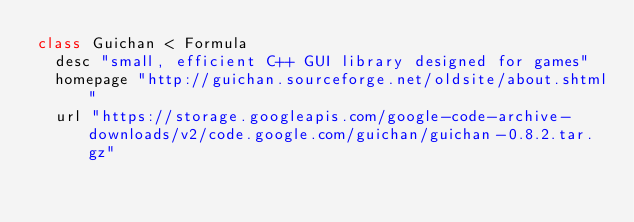Convert code to text. <code><loc_0><loc_0><loc_500><loc_500><_Ruby_>class Guichan < Formula
  desc "small, efficient C++ GUI library designed for games"
  homepage "http://guichan.sourceforge.net/oldsite/about.shtml"
  url "https://storage.googleapis.com/google-code-archive-downloads/v2/code.google.com/guichan/guichan-0.8.2.tar.gz"</code> 